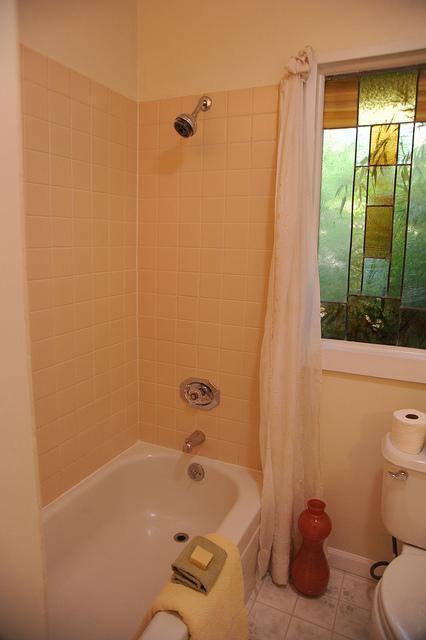How many bar of soaps are there?
Give a very brief answer. 1. 